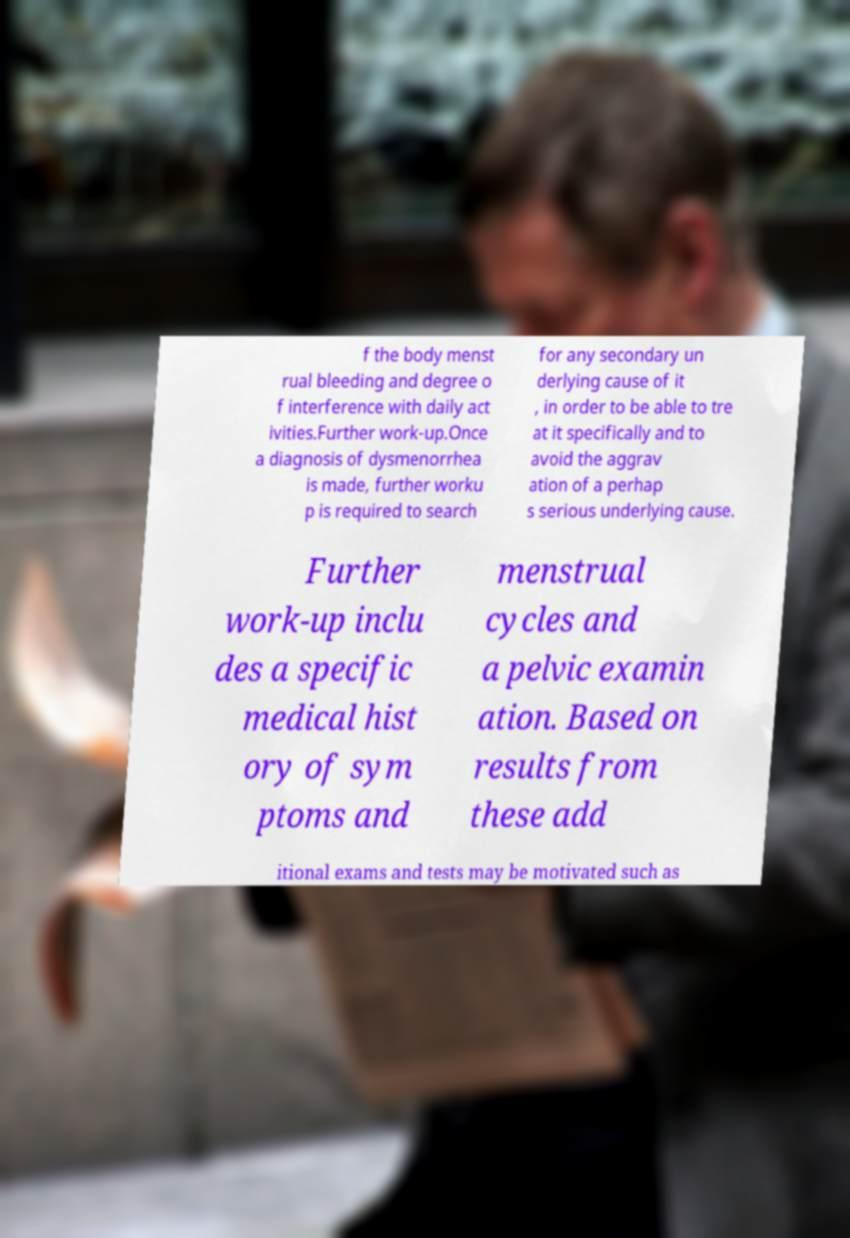Can you accurately transcribe the text from the provided image for me? f the body menst rual bleeding and degree o f interference with daily act ivities.Further work-up.Once a diagnosis of dysmenorrhea is made, further worku p is required to search for any secondary un derlying cause of it , in order to be able to tre at it specifically and to avoid the aggrav ation of a perhap s serious underlying cause. Further work-up inclu des a specific medical hist ory of sym ptoms and menstrual cycles and a pelvic examin ation. Based on results from these add itional exams and tests may be motivated such as 